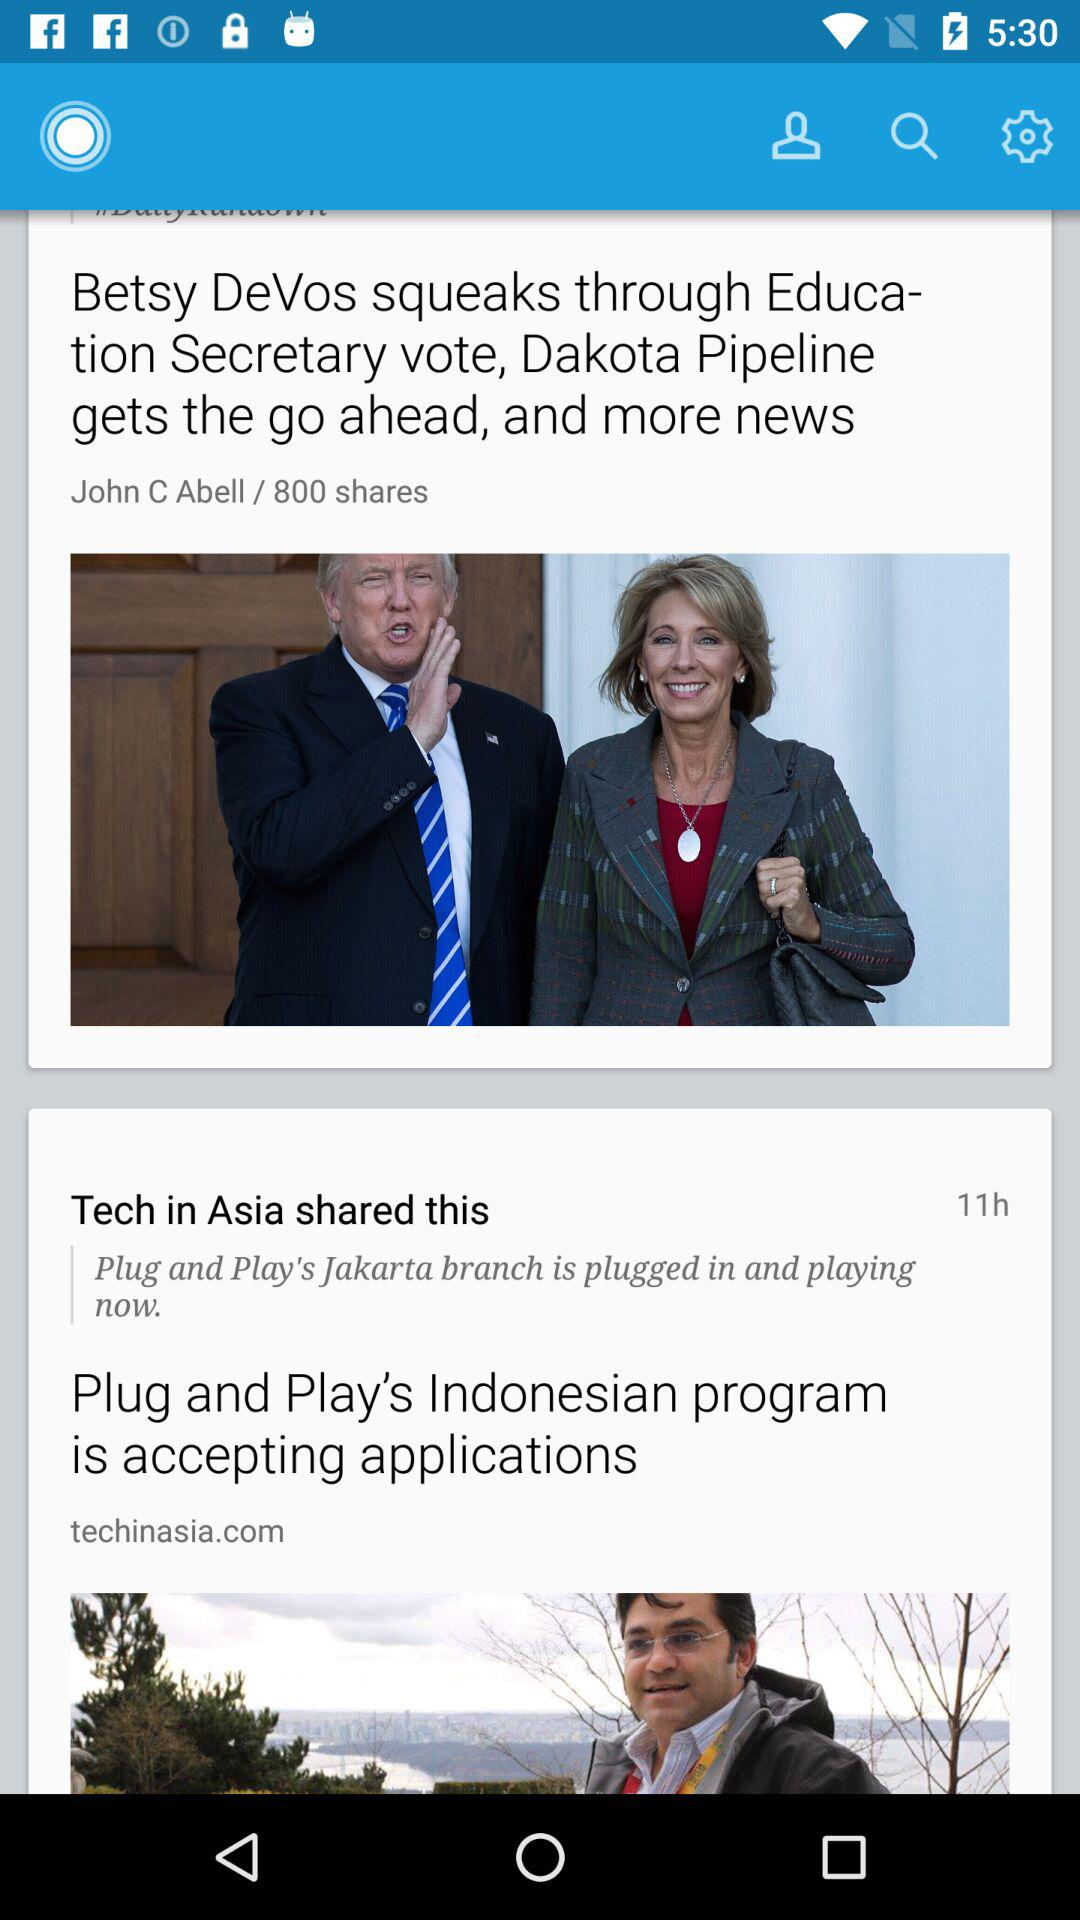When was the article by "Tech in Asia" shared? The article by "Tech in Asia" was shared 11 hours ago. 